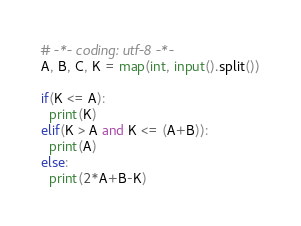<code> <loc_0><loc_0><loc_500><loc_500><_Python_># -*- coding: utf-8 -*-
A, B, C, K = map(int, input().split())

if(K <= A):
  print(K)
elif(K > A and K <= (A+B)):
  print(A)
else:
  print(2*A+B-K)
</code> 